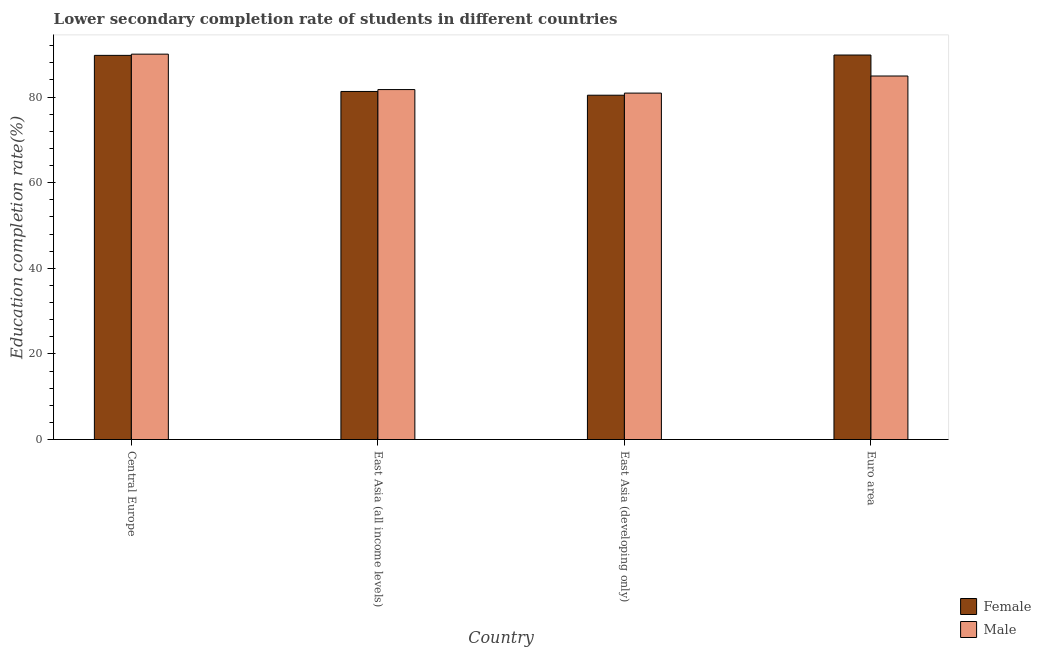How many different coloured bars are there?
Keep it short and to the point. 2. Are the number of bars on each tick of the X-axis equal?
Keep it short and to the point. Yes. What is the label of the 1st group of bars from the left?
Make the answer very short. Central Europe. What is the education completion rate of female students in East Asia (all income levels)?
Provide a short and direct response. 81.3. Across all countries, what is the maximum education completion rate of male students?
Offer a terse response. 90.01. Across all countries, what is the minimum education completion rate of female students?
Provide a succinct answer. 80.42. In which country was the education completion rate of female students maximum?
Give a very brief answer. Euro area. In which country was the education completion rate of female students minimum?
Keep it short and to the point. East Asia (developing only). What is the total education completion rate of male students in the graph?
Offer a very short reply. 337.58. What is the difference between the education completion rate of female students in Central Europe and that in Euro area?
Give a very brief answer. -0.08. What is the difference between the education completion rate of male students in Euro area and the education completion rate of female students in Central Europe?
Give a very brief answer. -4.82. What is the average education completion rate of male students per country?
Offer a terse response. 84.39. What is the difference between the education completion rate of male students and education completion rate of female students in Euro area?
Give a very brief answer. -4.9. What is the ratio of the education completion rate of male students in East Asia (all income levels) to that in East Asia (developing only)?
Provide a succinct answer. 1.01. Is the education completion rate of male students in East Asia (developing only) less than that in Euro area?
Offer a very short reply. Yes. What is the difference between the highest and the second highest education completion rate of male students?
Offer a very short reply. 5.11. What is the difference between the highest and the lowest education completion rate of female students?
Give a very brief answer. 9.39. What does the 2nd bar from the right in Euro area represents?
Keep it short and to the point. Female. How many bars are there?
Keep it short and to the point. 8. Are all the bars in the graph horizontal?
Keep it short and to the point. No. How many countries are there in the graph?
Make the answer very short. 4. Are the values on the major ticks of Y-axis written in scientific E-notation?
Offer a very short reply. No. Does the graph contain grids?
Your answer should be very brief. No. How many legend labels are there?
Provide a succinct answer. 2. How are the legend labels stacked?
Offer a very short reply. Vertical. What is the title of the graph?
Provide a succinct answer. Lower secondary completion rate of students in different countries. What is the label or title of the X-axis?
Ensure brevity in your answer.  Country. What is the label or title of the Y-axis?
Your answer should be compact. Education completion rate(%). What is the Education completion rate(%) in Female in Central Europe?
Ensure brevity in your answer.  89.73. What is the Education completion rate(%) of Male in Central Europe?
Provide a short and direct response. 90.01. What is the Education completion rate(%) in Female in East Asia (all income levels)?
Your answer should be very brief. 81.3. What is the Education completion rate(%) in Male in East Asia (all income levels)?
Make the answer very short. 81.74. What is the Education completion rate(%) of Female in East Asia (developing only)?
Offer a terse response. 80.42. What is the Education completion rate(%) in Male in East Asia (developing only)?
Offer a very short reply. 80.92. What is the Education completion rate(%) in Female in Euro area?
Make the answer very short. 89.81. What is the Education completion rate(%) in Male in Euro area?
Make the answer very short. 84.91. Across all countries, what is the maximum Education completion rate(%) of Female?
Ensure brevity in your answer.  89.81. Across all countries, what is the maximum Education completion rate(%) in Male?
Ensure brevity in your answer.  90.01. Across all countries, what is the minimum Education completion rate(%) in Female?
Offer a very short reply. 80.42. Across all countries, what is the minimum Education completion rate(%) of Male?
Give a very brief answer. 80.92. What is the total Education completion rate(%) of Female in the graph?
Offer a terse response. 341.26. What is the total Education completion rate(%) of Male in the graph?
Offer a terse response. 337.58. What is the difference between the Education completion rate(%) of Female in Central Europe and that in East Asia (all income levels)?
Keep it short and to the point. 8.43. What is the difference between the Education completion rate(%) of Male in Central Europe and that in East Asia (all income levels)?
Your response must be concise. 8.27. What is the difference between the Education completion rate(%) of Female in Central Europe and that in East Asia (developing only)?
Keep it short and to the point. 9.31. What is the difference between the Education completion rate(%) of Male in Central Europe and that in East Asia (developing only)?
Ensure brevity in your answer.  9.1. What is the difference between the Education completion rate(%) of Female in Central Europe and that in Euro area?
Make the answer very short. -0.08. What is the difference between the Education completion rate(%) of Male in Central Europe and that in Euro area?
Ensure brevity in your answer.  5.11. What is the difference between the Education completion rate(%) in Female in East Asia (all income levels) and that in East Asia (developing only)?
Keep it short and to the point. 0.88. What is the difference between the Education completion rate(%) of Male in East Asia (all income levels) and that in East Asia (developing only)?
Offer a terse response. 0.82. What is the difference between the Education completion rate(%) of Female in East Asia (all income levels) and that in Euro area?
Keep it short and to the point. -8.51. What is the difference between the Education completion rate(%) in Male in East Asia (all income levels) and that in Euro area?
Keep it short and to the point. -3.17. What is the difference between the Education completion rate(%) of Female in East Asia (developing only) and that in Euro area?
Offer a terse response. -9.39. What is the difference between the Education completion rate(%) of Male in East Asia (developing only) and that in Euro area?
Provide a short and direct response. -3.99. What is the difference between the Education completion rate(%) in Female in Central Europe and the Education completion rate(%) in Male in East Asia (all income levels)?
Offer a very short reply. 7.99. What is the difference between the Education completion rate(%) in Female in Central Europe and the Education completion rate(%) in Male in East Asia (developing only)?
Your answer should be compact. 8.81. What is the difference between the Education completion rate(%) in Female in Central Europe and the Education completion rate(%) in Male in Euro area?
Provide a succinct answer. 4.82. What is the difference between the Education completion rate(%) of Female in East Asia (all income levels) and the Education completion rate(%) of Male in East Asia (developing only)?
Your answer should be very brief. 0.38. What is the difference between the Education completion rate(%) in Female in East Asia (all income levels) and the Education completion rate(%) in Male in Euro area?
Provide a succinct answer. -3.61. What is the difference between the Education completion rate(%) of Female in East Asia (developing only) and the Education completion rate(%) of Male in Euro area?
Give a very brief answer. -4.49. What is the average Education completion rate(%) of Female per country?
Provide a short and direct response. 85.31. What is the average Education completion rate(%) of Male per country?
Provide a succinct answer. 84.39. What is the difference between the Education completion rate(%) in Female and Education completion rate(%) in Male in Central Europe?
Offer a very short reply. -0.28. What is the difference between the Education completion rate(%) in Female and Education completion rate(%) in Male in East Asia (all income levels)?
Your answer should be very brief. -0.44. What is the difference between the Education completion rate(%) in Female and Education completion rate(%) in Male in East Asia (developing only)?
Ensure brevity in your answer.  -0.5. What is the difference between the Education completion rate(%) of Female and Education completion rate(%) of Male in Euro area?
Provide a succinct answer. 4.9. What is the ratio of the Education completion rate(%) in Female in Central Europe to that in East Asia (all income levels)?
Provide a succinct answer. 1.1. What is the ratio of the Education completion rate(%) in Male in Central Europe to that in East Asia (all income levels)?
Provide a short and direct response. 1.1. What is the ratio of the Education completion rate(%) of Female in Central Europe to that in East Asia (developing only)?
Keep it short and to the point. 1.12. What is the ratio of the Education completion rate(%) of Male in Central Europe to that in East Asia (developing only)?
Your answer should be compact. 1.11. What is the ratio of the Education completion rate(%) in Female in Central Europe to that in Euro area?
Offer a very short reply. 1. What is the ratio of the Education completion rate(%) in Male in Central Europe to that in Euro area?
Offer a terse response. 1.06. What is the ratio of the Education completion rate(%) in Female in East Asia (all income levels) to that in East Asia (developing only)?
Ensure brevity in your answer.  1.01. What is the ratio of the Education completion rate(%) of Male in East Asia (all income levels) to that in East Asia (developing only)?
Give a very brief answer. 1.01. What is the ratio of the Education completion rate(%) of Female in East Asia (all income levels) to that in Euro area?
Make the answer very short. 0.91. What is the ratio of the Education completion rate(%) in Male in East Asia (all income levels) to that in Euro area?
Your answer should be compact. 0.96. What is the ratio of the Education completion rate(%) in Female in East Asia (developing only) to that in Euro area?
Your response must be concise. 0.9. What is the ratio of the Education completion rate(%) of Male in East Asia (developing only) to that in Euro area?
Provide a succinct answer. 0.95. What is the difference between the highest and the second highest Education completion rate(%) of Female?
Give a very brief answer. 0.08. What is the difference between the highest and the second highest Education completion rate(%) of Male?
Give a very brief answer. 5.11. What is the difference between the highest and the lowest Education completion rate(%) of Female?
Offer a terse response. 9.39. What is the difference between the highest and the lowest Education completion rate(%) of Male?
Offer a very short reply. 9.1. 